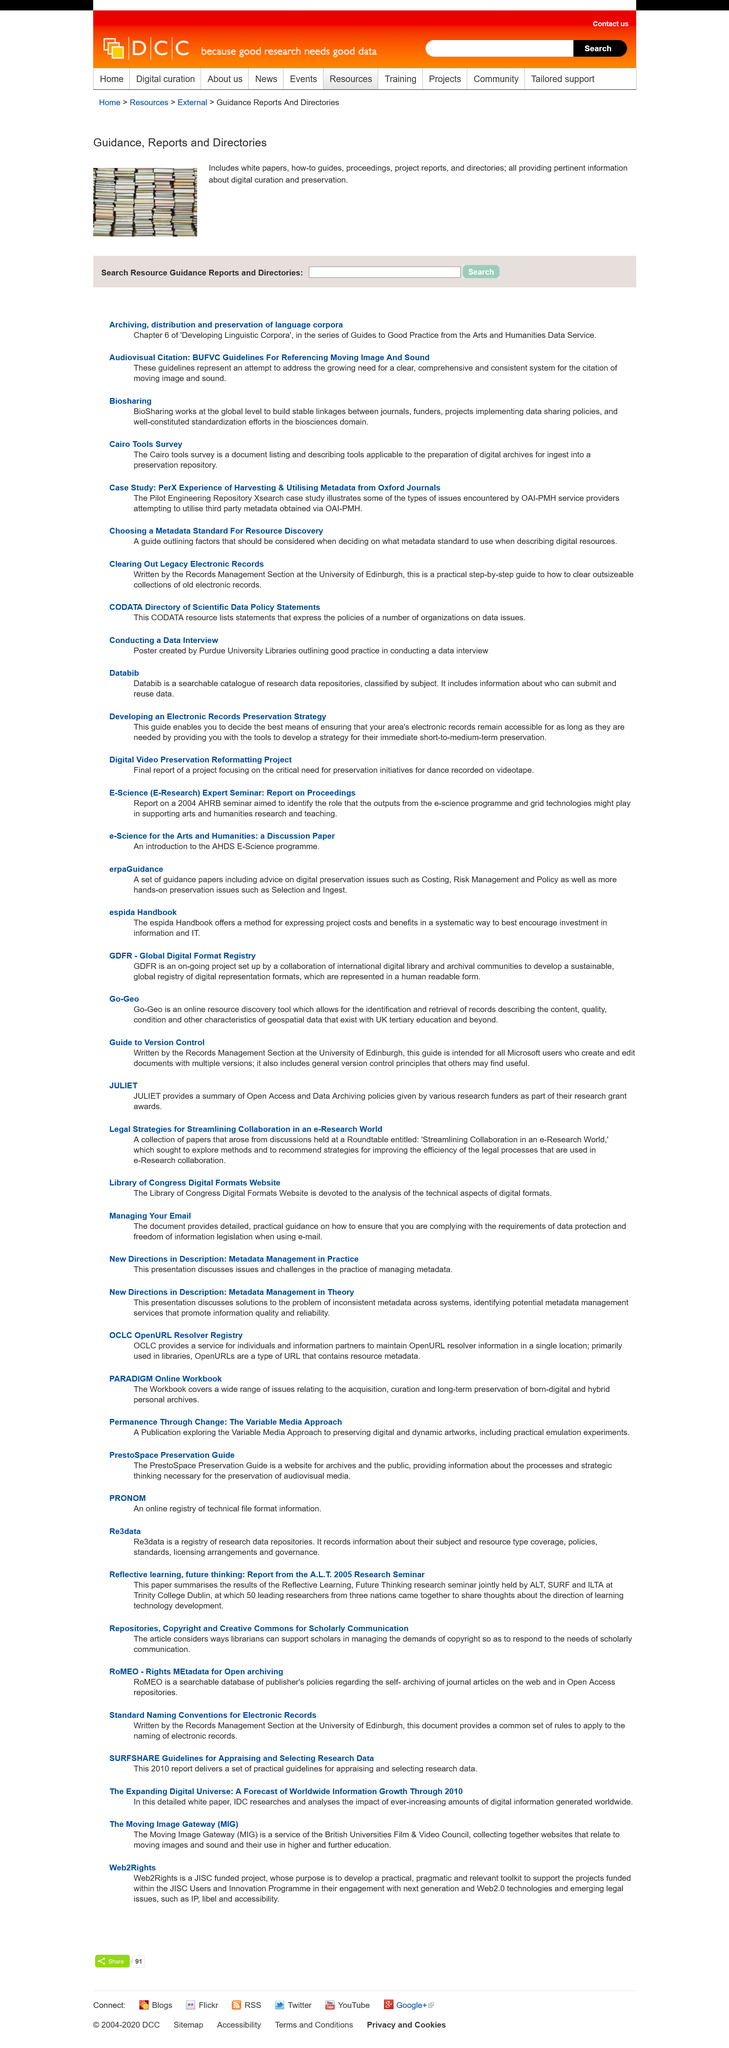Outline some significant characteristics in this image. The BUFVC Guidelines for Referencing Moving Image and Sound are a system designed to address the need for clear, comprehensive, and consistent citation of moving images and sound. There is a critical need for a well-defined and uniform system for citing moving images and sound. BioSharing effectively addresses the challenge of sharing data and resources at the global level and has proven to be an effective approach in addressing the issue of data and resource sharing in the life sciences domain. 